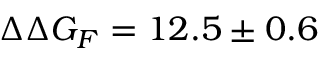<formula> <loc_0><loc_0><loc_500><loc_500>\Delta \Delta G _ { F } = 1 2 . 5 \pm 0 . 6</formula> 